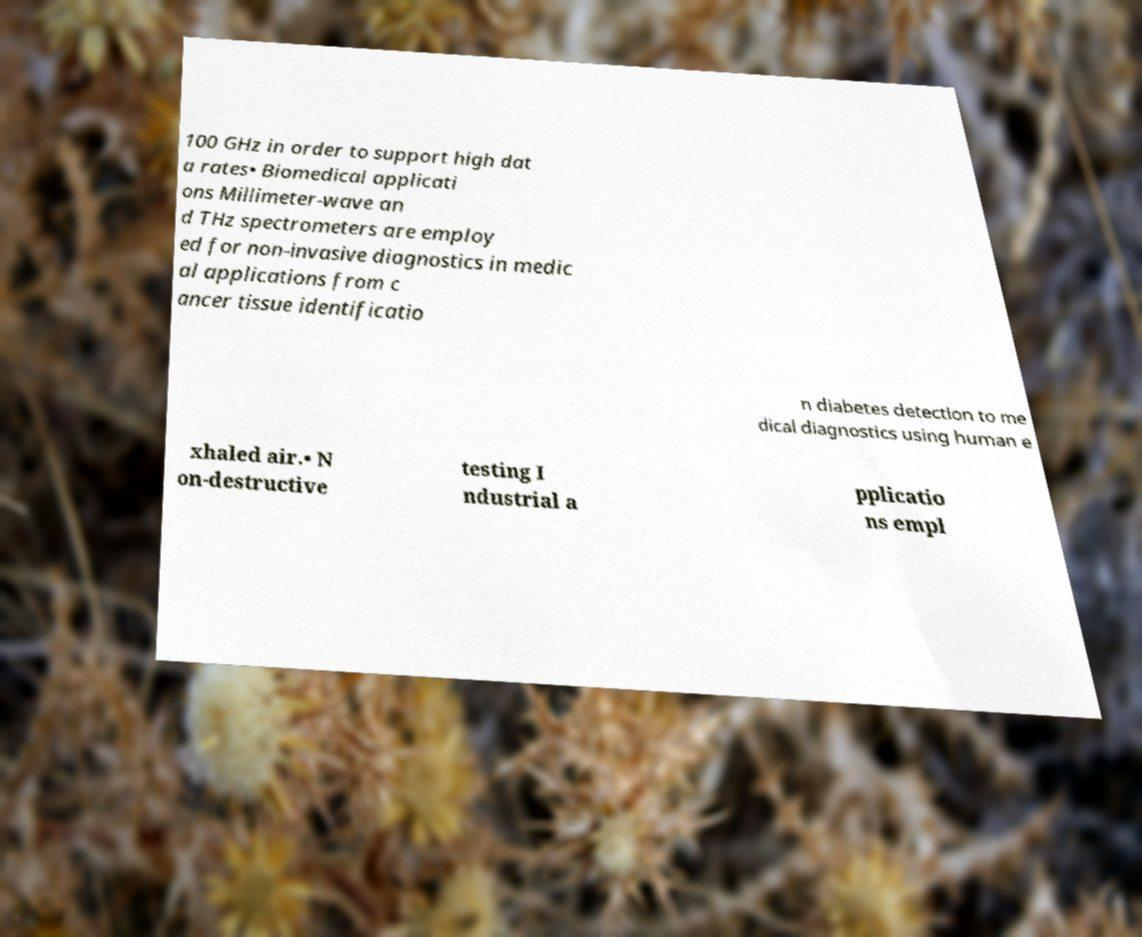Can you accurately transcribe the text from the provided image for me? 100 GHz in order to support high dat a rates• Biomedical applicati ons Millimeter-wave an d THz spectrometers are employ ed for non-invasive diagnostics in medic al applications from c ancer tissue identificatio n diabetes detection to me dical diagnostics using human e xhaled air.• N on-destructive testing I ndustrial a pplicatio ns empl 